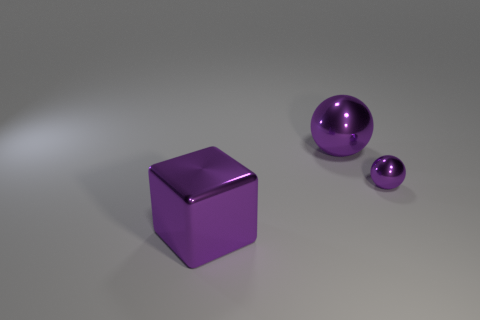Is the color of the tiny metallic object the same as the metallic block?
Provide a succinct answer. Yes. Is the number of purple spheres on the right side of the big ball greater than the number of small green cubes?
Your response must be concise. Yes. There is a large object that is behind the large purple block; what number of shiny balls are in front of it?
Keep it short and to the point. 1. Are there fewer small things that are left of the large metallic ball than big red balls?
Provide a short and direct response. No. Are there any big objects that are to the right of the metal thing that is to the left of the big purple thing that is behind the metallic cube?
Make the answer very short. Yes. Are the tiny purple ball and the big purple thing right of the large metallic block made of the same material?
Offer a very short reply. Yes. Is there a big object of the same color as the big metallic sphere?
Provide a short and direct response. Yes. There is a purple sphere in front of the big object behind the metallic thing to the right of the large metal ball; how big is it?
Your answer should be compact. Small. There is a tiny object; does it have the same shape as the large purple metal thing that is in front of the big purple metallic ball?
Provide a succinct answer. No. How many other objects are the same size as the metal block?
Your response must be concise. 1. 